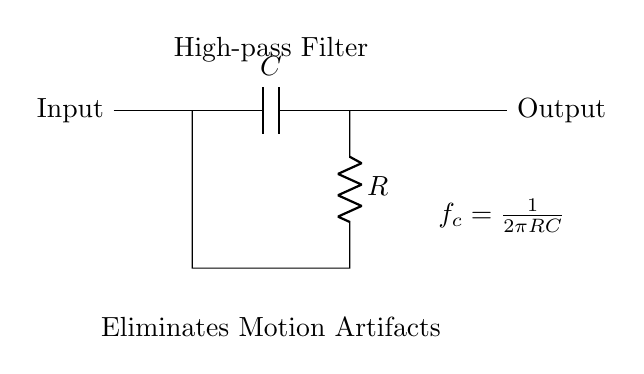What are the components in this high-pass filter? The circuit includes one capacitor and one resistor, which are essential components for constructing a high-pass filter. These elements are typically marked in the diagram.
Answer: capacitor and resistor What does the capacitor do in this circuit? The capacitor blocks low-frequency signals while allowing high-frequency signals to pass, which is a critical function of a high-pass filter. This is because it charges at lower frequencies and thus reduces their impact on the output.
Answer: Block low frequencies What is the cutoff frequency formula shown in the circuit? The cutoff frequency is indicated in the diagram as fc = 1 / (2πRC). To obtain this formula, the relationship between the capacitor's reactance and the resistor is utilized, determining the frequency at which the output is significantly reduced.
Answer: 1 over 2 pi RC What happens to motion artifacts above the cutoff frequency? Motion artifacts that are above the cutoff frequency are allowed to pass through the filter, while those below are attenuated. This filtration process is designed to stabilize patient monitoring by removing unwanted low-frequency noise.
Answer: Passed through How does increasing the resistance affect the cutoff frequency? Increasing the resistance R will decrease the cutoff frequency fc, since they are inversely related in the formula fc = 1 / (2πRC). This means that fewer frequencies will be allowed to pass through when resistance is increased.
Answer: Decreases cutoff frequency What is the purpose of the high-pass filter in patient monitoring systems? The high-pass filter's primary purpose is to eliminate motion artifacts that can interfere with the accurate monitoring of a patient's vital signs, ensuring clearer signal quality for medical assessment.
Answer: Eliminate motion artifacts 